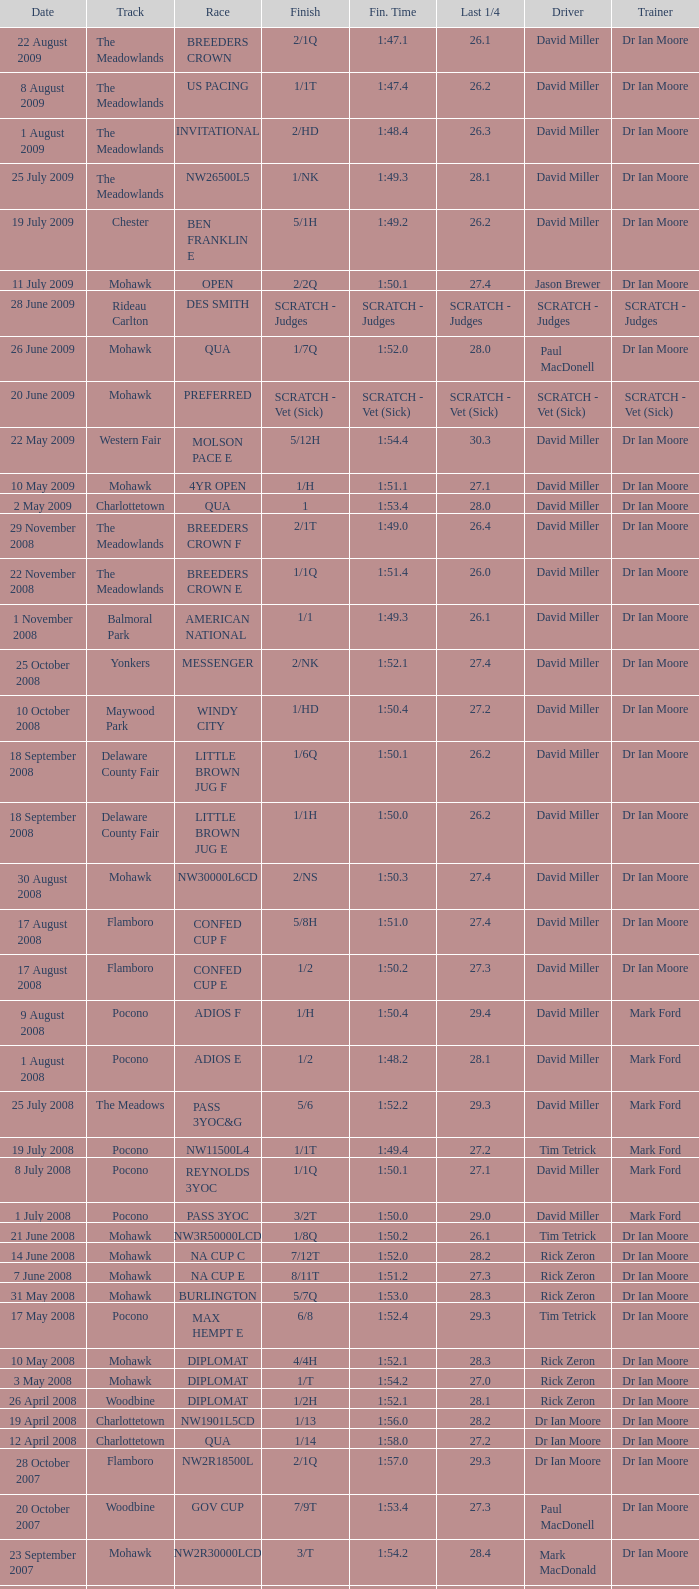At the meadowlands track, what is the final time for a finish with a 2/1q? 1:47.1. 